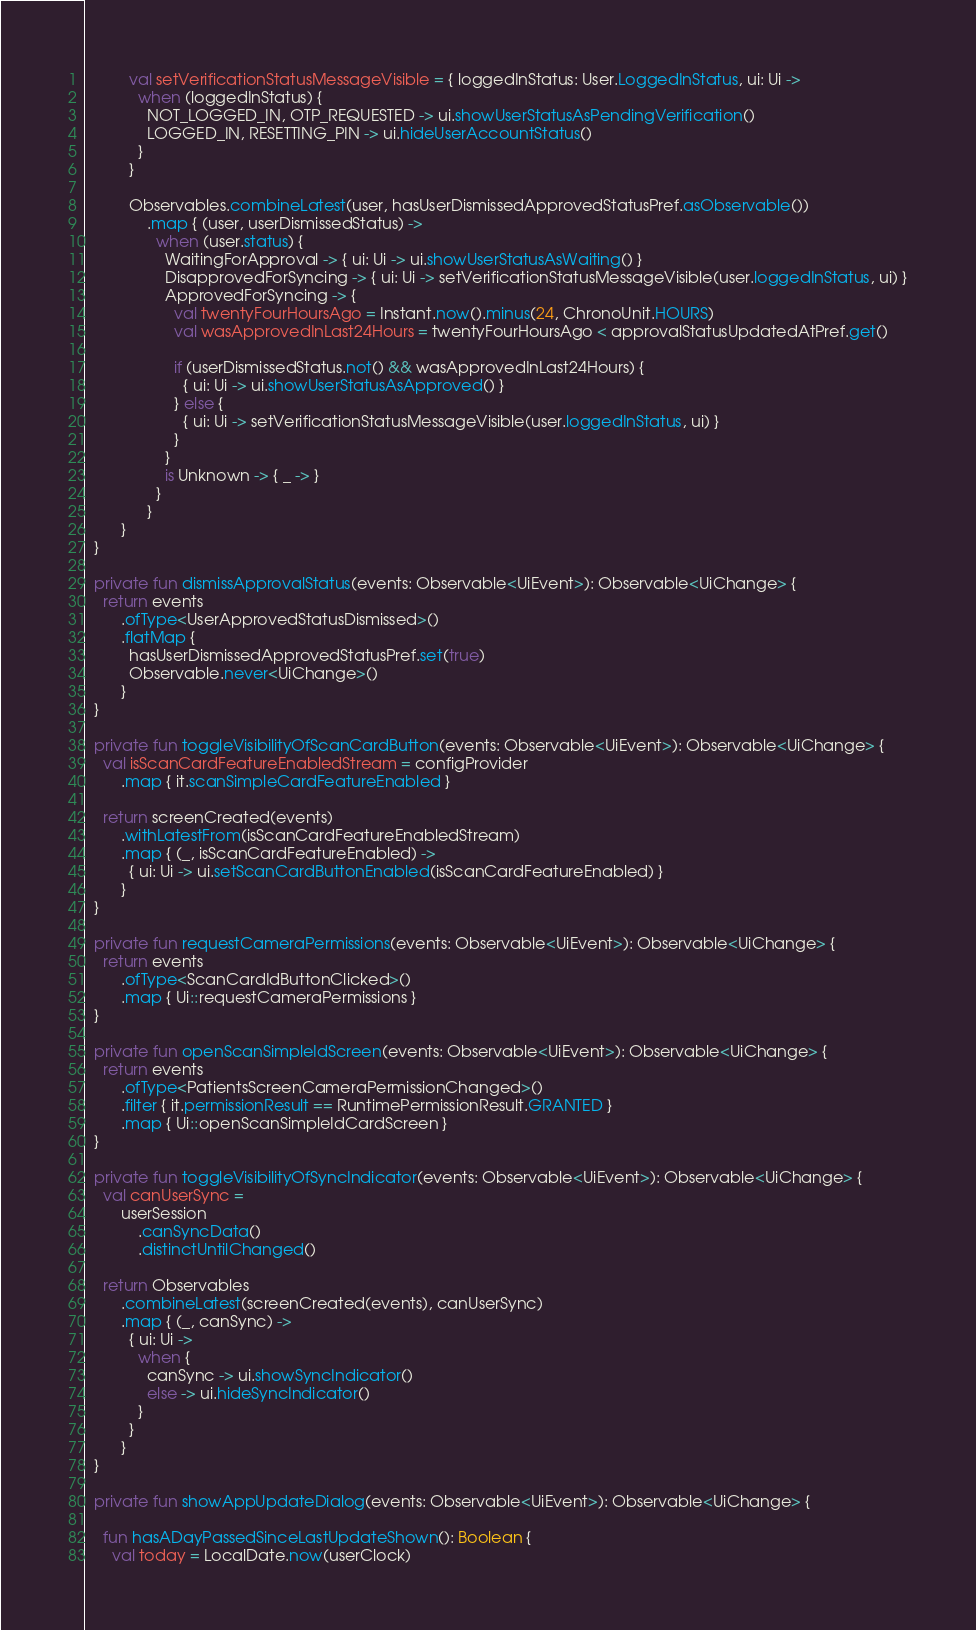Convert code to text. <code><loc_0><loc_0><loc_500><loc_500><_Kotlin_>          val setVerificationStatusMessageVisible = { loggedInStatus: User.LoggedInStatus, ui: Ui ->
            when (loggedInStatus) {
              NOT_LOGGED_IN, OTP_REQUESTED -> ui.showUserStatusAsPendingVerification()
              LOGGED_IN, RESETTING_PIN -> ui.hideUserAccountStatus()
            }
          }

          Observables.combineLatest(user, hasUserDismissedApprovedStatusPref.asObservable())
              .map { (user, userDismissedStatus) ->
                when (user.status) {
                  WaitingForApproval -> { ui: Ui -> ui.showUserStatusAsWaiting() }
                  DisapprovedForSyncing -> { ui: Ui -> setVerificationStatusMessageVisible(user.loggedInStatus, ui) }
                  ApprovedForSyncing -> {
                    val twentyFourHoursAgo = Instant.now().minus(24, ChronoUnit.HOURS)
                    val wasApprovedInLast24Hours = twentyFourHoursAgo < approvalStatusUpdatedAtPref.get()

                    if (userDismissedStatus.not() && wasApprovedInLast24Hours) {
                      { ui: Ui -> ui.showUserStatusAsApproved() }
                    } else {
                      { ui: Ui -> setVerificationStatusMessageVisible(user.loggedInStatus, ui) }
                    }
                  }
                  is Unknown -> { _ -> }
                }
              }
        }
  }

  private fun dismissApprovalStatus(events: Observable<UiEvent>): Observable<UiChange> {
    return events
        .ofType<UserApprovedStatusDismissed>()
        .flatMap {
          hasUserDismissedApprovedStatusPref.set(true)
          Observable.never<UiChange>()
        }
  }

  private fun toggleVisibilityOfScanCardButton(events: Observable<UiEvent>): Observable<UiChange> {
    val isScanCardFeatureEnabledStream = configProvider
        .map { it.scanSimpleCardFeatureEnabled }

    return screenCreated(events)
        .withLatestFrom(isScanCardFeatureEnabledStream)
        .map { (_, isScanCardFeatureEnabled) ->
          { ui: Ui -> ui.setScanCardButtonEnabled(isScanCardFeatureEnabled) }
        }
  }

  private fun requestCameraPermissions(events: Observable<UiEvent>): Observable<UiChange> {
    return events
        .ofType<ScanCardIdButtonClicked>()
        .map { Ui::requestCameraPermissions }
  }

  private fun openScanSimpleIdScreen(events: Observable<UiEvent>): Observable<UiChange> {
    return events
        .ofType<PatientsScreenCameraPermissionChanged>()
        .filter { it.permissionResult == RuntimePermissionResult.GRANTED }
        .map { Ui::openScanSimpleIdCardScreen }
  }

  private fun toggleVisibilityOfSyncIndicator(events: Observable<UiEvent>): Observable<UiChange> {
    val canUserSync =
        userSession
            .canSyncData()
            .distinctUntilChanged()

    return Observables
        .combineLatest(screenCreated(events), canUserSync)
        .map { (_, canSync) ->
          { ui: Ui ->
            when {
              canSync -> ui.showSyncIndicator()
              else -> ui.hideSyncIndicator()
            }
          }
        }
  }

  private fun showAppUpdateDialog(events: Observable<UiEvent>): Observable<UiChange> {

    fun hasADayPassedSinceLastUpdateShown(): Boolean {
      val today = LocalDate.now(userClock)</code> 